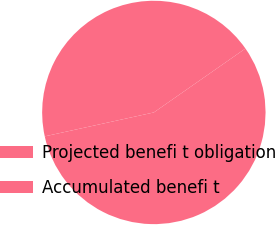<chart> <loc_0><loc_0><loc_500><loc_500><pie_chart><fcel>Projected benefi t obligation<fcel>Accumulated benefi t<nl><fcel>56.26%<fcel>43.74%<nl></chart> 